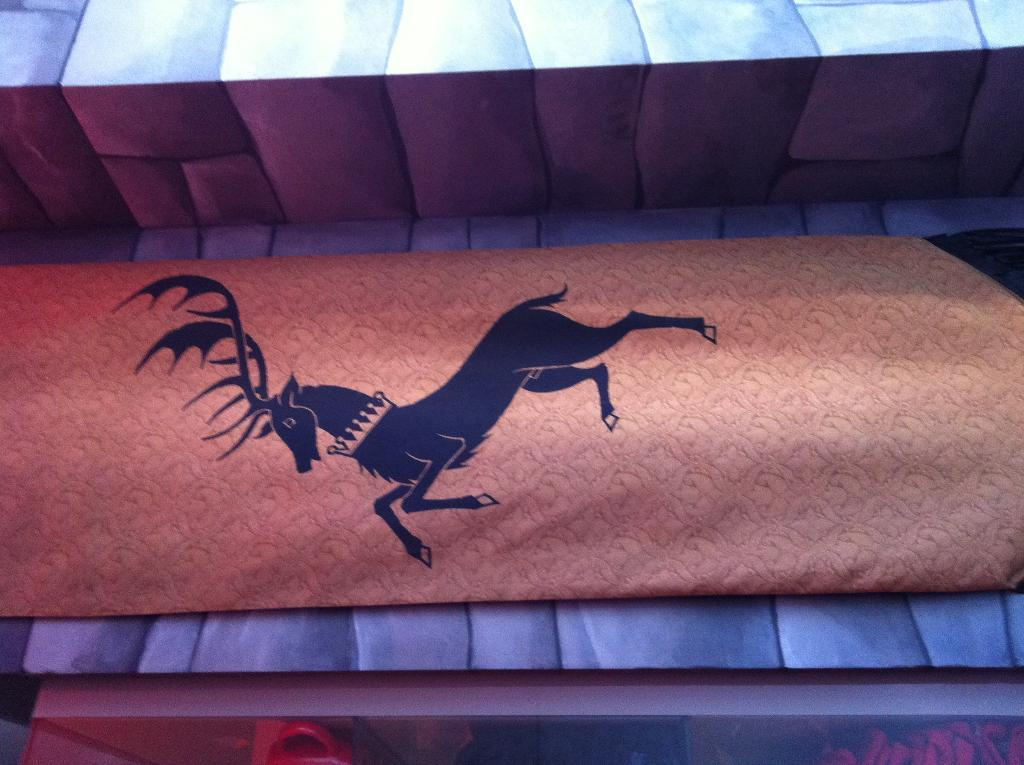What is the main object in the image? There is a board in the image. What is depicted on the board? There is a horse picture on the board. What can be seen in the background of the image? There is a wall in the background of the image. What substance is the horse stepping on in the image? There is no horse present in the image, as it is a picture of a horse on the board. How many feet can be seen in the image? There are no feet visible in the image, as it features a board with a horse picture and a wall in the background. 